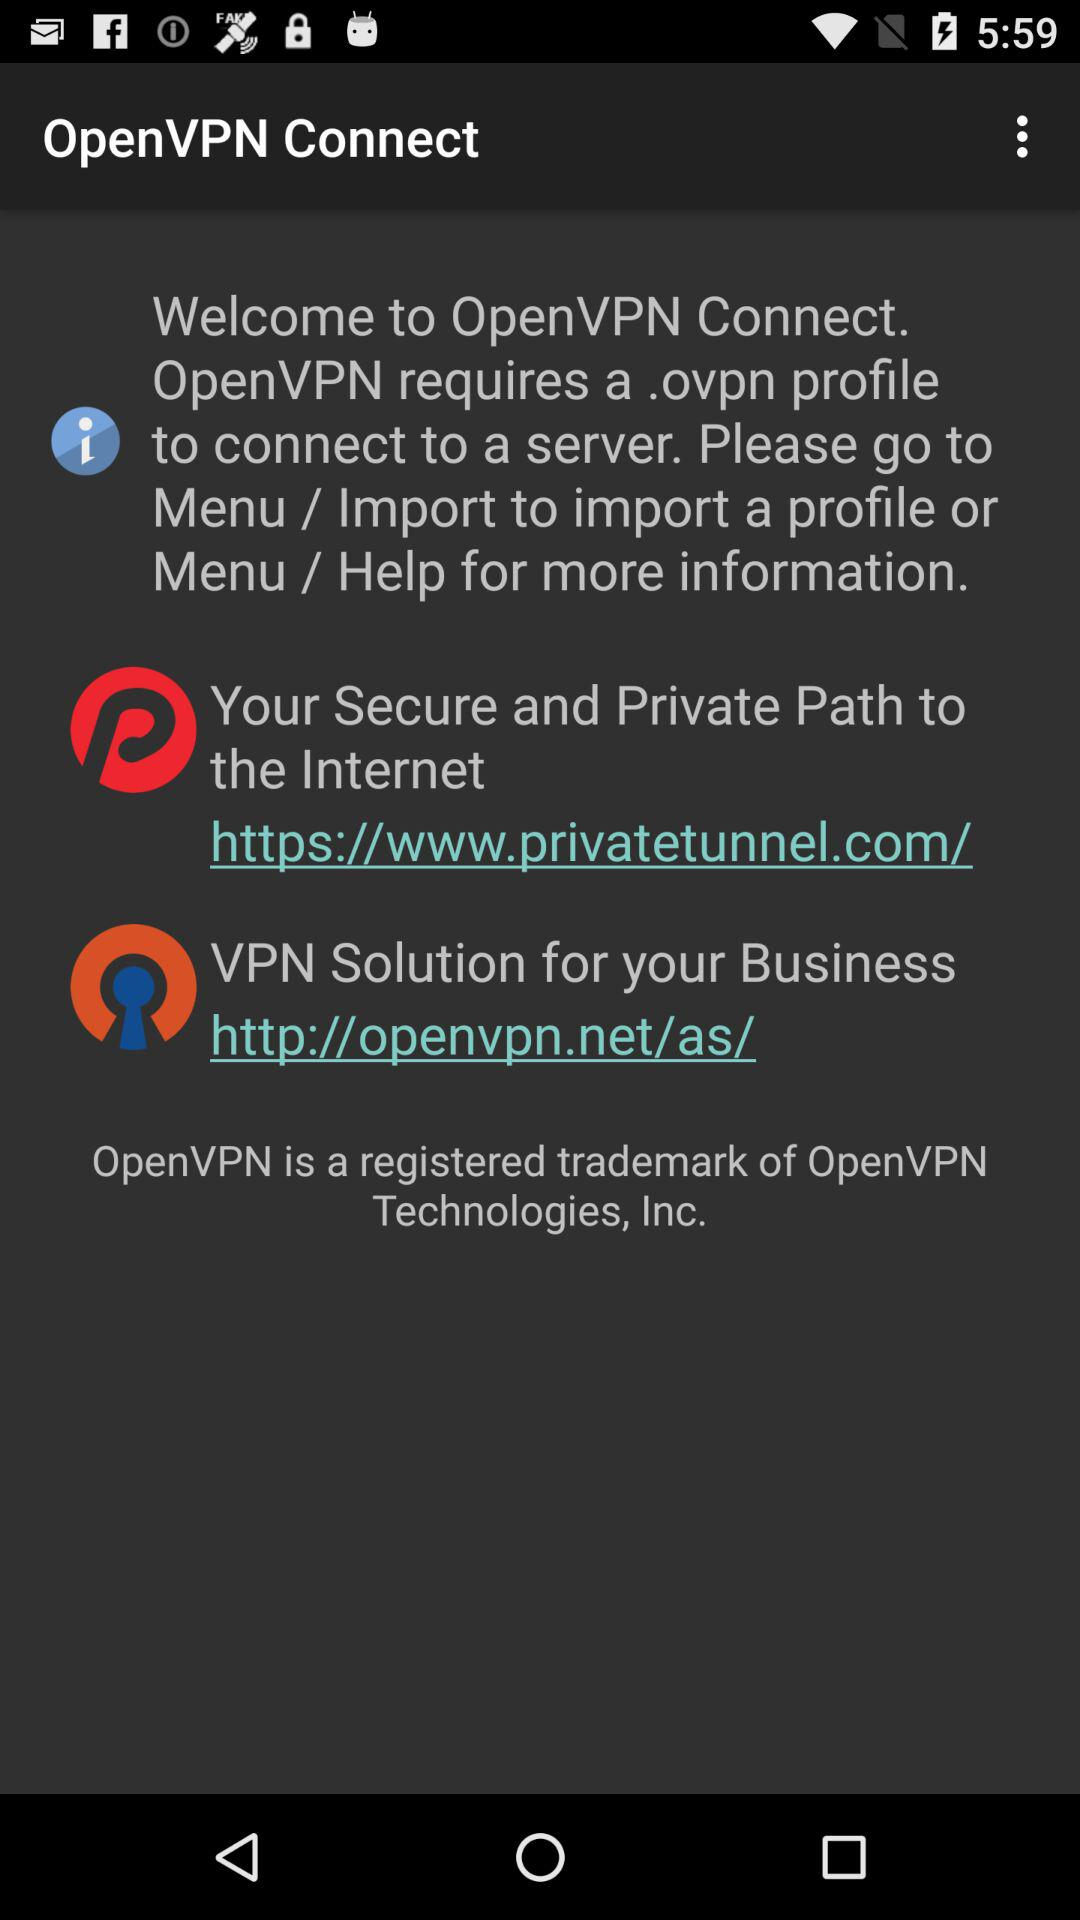What are benefits provided while using the "OpenVPN Connect "?
When the provided information is insufficient, respond with <no answer>. <no answer> 